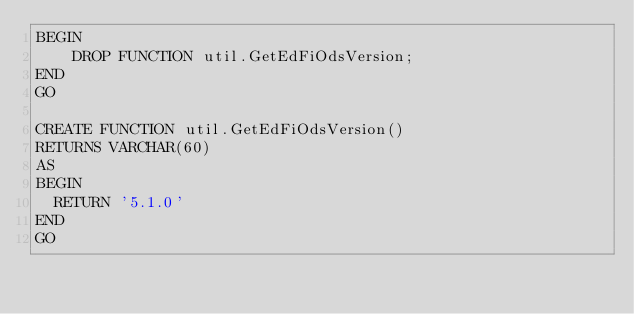<code> <loc_0><loc_0><loc_500><loc_500><_SQL_>BEGIN
    DROP FUNCTION util.GetEdFiOdsVersion;
END
GO

CREATE FUNCTION util.GetEdFiOdsVersion()
RETURNS VARCHAR(60)
AS
BEGIN
	RETURN '5.1.0'
END
GO</code> 